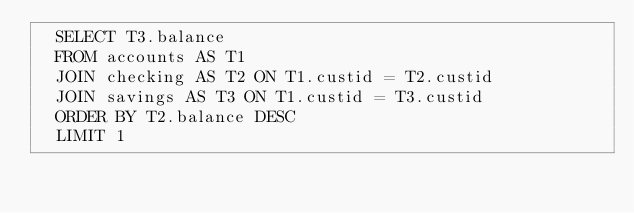<code> <loc_0><loc_0><loc_500><loc_500><_YAML_>  SELECT T3.balance
  FROM accounts AS T1
  JOIN checking AS T2 ON T1.custid = T2.custid
  JOIN savings AS T3 ON T1.custid = T3.custid
  ORDER BY T2.balance DESC
  LIMIT 1</code> 